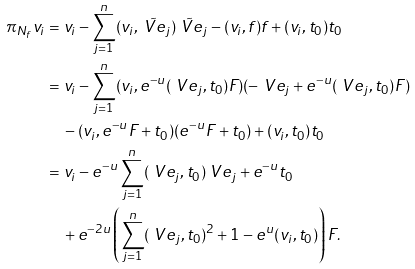Convert formula to latex. <formula><loc_0><loc_0><loc_500><loc_500>\pi _ { N _ { f } } v _ { i } & = v _ { i } - \sum _ { j = 1 } ^ { n } ( v _ { i } , \tilde { \ V e } _ { j } ) \tilde { \ V e } _ { j } - ( v _ { i } , f ) f + ( v _ { i } , t _ { 0 } ) t _ { 0 } \\ & = v _ { i } - \sum _ { j = 1 } ^ { n } ( v _ { i } , e ^ { - u } ( \ V e _ { j } , t _ { 0 } ) F ) ( - \ V e _ { j } + e ^ { - u } ( \ V e _ { j } , t _ { 0 } ) F ) \\ & \quad - ( v _ { i } , e ^ { - u } F + t _ { 0 } ) ( e ^ { - u } F + t _ { 0 } ) + ( v _ { i } , t _ { 0 } ) t _ { 0 } \\ & = v _ { i } - e ^ { - u } \sum _ { j = 1 } ^ { n } ( \ V e _ { j } , t _ { 0 } ) \ V e _ { j } + e ^ { - u } t _ { 0 } \\ & \quad + e ^ { - 2 u } \left ( \sum _ { j = 1 } ^ { n } ( \ V e _ { j } , t _ { 0 } ) ^ { 2 } + 1 - e ^ { u } ( v _ { i } , t _ { 0 } ) \right ) F .</formula> 